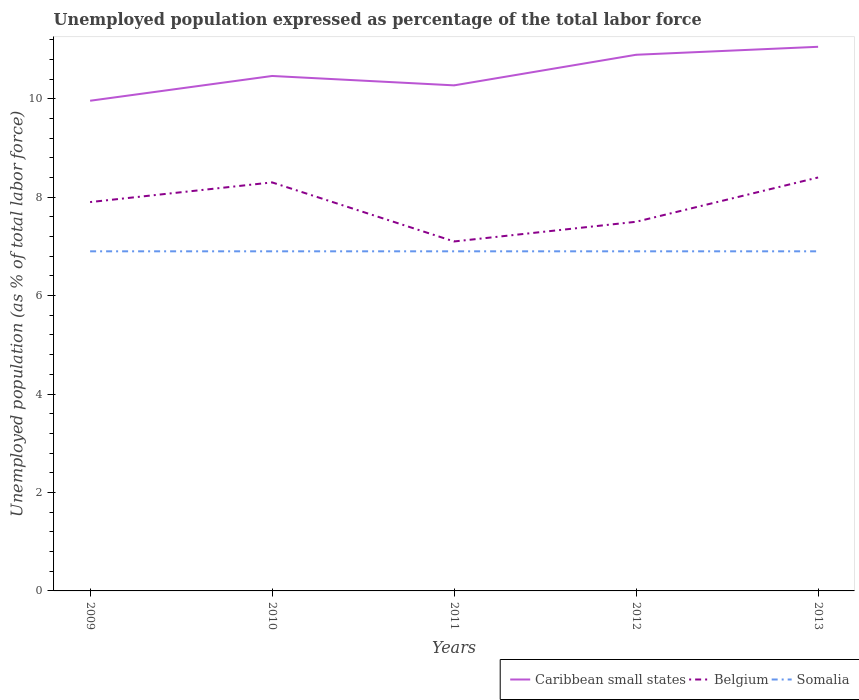Does the line corresponding to Caribbean small states intersect with the line corresponding to Somalia?
Provide a short and direct response. No. Is the number of lines equal to the number of legend labels?
Give a very brief answer. Yes. Across all years, what is the maximum unemployment in in Belgium?
Keep it short and to the point. 7.1. In which year was the unemployment in in Caribbean small states maximum?
Offer a very short reply. 2009. What is the total unemployment in in Caribbean small states in the graph?
Keep it short and to the point. -0.5. What is the difference between the highest and the second highest unemployment in in Belgium?
Offer a very short reply. 1.3. How many lines are there?
Keep it short and to the point. 3. Does the graph contain grids?
Offer a very short reply. No. Where does the legend appear in the graph?
Offer a very short reply. Bottom right. How many legend labels are there?
Offer a terse response. 3. What is the title of the graph?
Your answer should be very brief. Unemployed population expressed as percentage of the total labor force. What is the label or title of the Y-axis?
Make the answer very short. Unemployed population (as % of total labor force). What is the Unemployed population (as % of total labor force) of Caribbean small states in 2009?
Your response must be concise. 9.96. What is the Unemployed population (as % of total labor force) of Belgium in 2009?
Offer a terse response. 7.9. What is the Unemployed population (as % of total labor force) of Somalia in 2009?
Offer a very short reply. 6.9. What is the Unemployed population (as % of total labor force) of Caribbean small states in 2010?
Your response must be concise. 10.46. What is the Unemployed population (as % of total labor force) of Belgium in 2010?
Your answer should be compact. 8.3. What is the Unemployed population (as % of total labor force) of Somalia in 2010?
Give a very brief answer. 6.9. What is the Unemployed population (as % of total labor force) in Caribbean small states in 2011?
Keep it short and to the point. 10.27. What is the Unemployed population (as % of total labor force) in Belgium in 2011?
Your response must be concise. 7.1. What is the Unemployed population (as % of total labor force) of Somalia in 2011?
Provide a short and direct response. 6.9. What is the Unemployed population (as % of total labor force) in Caribbean small states in 2012?
Your answer should be very brief. 10.89. What is the Unemployed population (as % of total labor force) in Belgium in 2012?
Your answer should be compact. 7.5. What is the Unemployed population (as % of total labor force) of Somalia in 2012?
Keep it short and to the point. 6.9. What is the Unemployed population (as % of total labor force) in Caribbean small states in 2013?
Ensure brevity in your answer.  11.05. What is the Unemployed population (as % of total labor force) in Belgium in 2013?
Ensure brevity in your answer.  8.4. What is the Unemployed population (as % of total labor force) of Somalia in 2013?
Your answer should be compact. 6.9. Across all years, what is the maximum Unemployed population (as % of total labor force) of Caribbean small states?
Provide a succinct answer. 11.05. Across all years, what is the maximum Unemployed population (as % of total labor force) in Belgium?
Provide a short and direct response. 8.4. Across all years, what is the maximum Unemployed population (as % of total labor force) in Somalia?
Make the answer very short. 6.9. Across all years, what is the minimum Unemployed population (as % of total labor force) in Caribbean small states?
Offer a terse response. 9.96. Across all years, what is the minimum Unemployed population (as % of total labor force) in Belgium?
Provide a short and direct response. 7.1. Across all years, what is the minimum Unemployed population (as % of total labor force) of Somalia?
Your response must be concise. 6.9. What is the total Unemployed population (as % of total labor force) in Caribbean small states in the graph?
Provide a short and direct response. 52.64. What is the total Unemployed population (as % of total labor force) in Belgium in the graph?
Offer a very short reply. 39.2. What is the total Unemployed population (as % of total labor force) in Somalia in the graph?
Provide a succinct answer. 34.5. What is the difference between the Unemployed population (as % of total labor force) in Caribbean small states in 2009 and that in 2010?
Your answer should be compact. -0.5. What is the difference between the Unemployed population (as % of total labor force) in Somalia in 2009 and that in 2010?
Provide a short and direct response. 0. What is the difference between the Unemployed population (as % of total labor force) in Caribbean small states in 2009 and that in 2011?
Offer a very short reply. -0.31. What is the difference between the Unemployed population (as % of total labor force) of Belgium in 2009 and that in 2011?
Provide a short and direct response. 0.8. What is the difference between the Unemployed population (as % of total labor force) in Somalia in 2009 and that in 2011?
Offer a very short reply. 0. What is the difference between the Unemployed population (as % of total labor force) in Caribbean small states in 2009 and that in 2012?
Your response must be concise. -0.93. What is the difference between the Unemployed population (as % of total labor force) in Somalia in 2009 and that in 2012?
Provide a short and direct response. 0. What is the difference between the Unemployed population (as % of total labor force) of Caribbean small states in 2009 and that in 2013?
Provide a short and direct response. -1.1. What is the difference between the Unemployed population (as % of total labor force) of Somalia in 2009 and that in 2013?
Your answer should be compact. 0. What is the difference between the Unemployed population (as % of total labor force) in Caribbean small states in 2010 and that in 2011?
Your response must be concise. 0.19. What is the difference between the Unemployed population (as % of total labor force) of Belgium in 2010 and that in 2011?
Your answer should be compact. 1.2. What is the difference between the Unemployed population (as % of total labor force) in Somalia in 2010 and that in 2011?
Make the answer very short. 0. What is the difference between the Unemployed population (as % of total labor force) in Caribbean small states in 2010 and that in 2012?
Provide a short and direct response. -0.43. What is the difference between the Unemployed population (as % of total labor force) in Caribbean small states in 2010 and that in 2013?
Keep it short and to the point. -0.59. What is the difference between the Unemployed population (as % of total labor force) in Somalia in 2010 and that in 2013?
Give a very brief answer. 0. What is the difference between the Unemployed population (as % of total labor force) in Caribbean small states in 2011 and that in 2012?
Offer a terse response. -0.62. What is the difference between the Unemployed population (as % of total labor force) of Belgium in 2011 and that in 2012?
Keep it short and to the point. -0.4. What is the difference between the Unemployed population (as % of total labor force) of Caribbean small states in 2011 and that in 2013?
Keep it short and to the point. -0.78. What is the difference between the Unemployed population (as % of total labor force) in Caribbean small states in 2012 and that in 2013?
Offer a very short reply. -0.16. What is the difference between the Unemployed population (as % of total labor force) of Belgium in 2012 and that in 2013?
Your answer should be compact. -0.9. What is the difference between the Unemployed population (as % of total labor force) in Caribbean small states in 2009 and the Unemployed population (as % of total labor force) in Belgium in 2010?
Your response must be concise. 1.66. What is the difference between the Unemployed population (as % of total labor force) in Caribbean small states in 2009 and the Unemployed population (as % of total labor force) in Somalia in 2010?
Your answer should be compact. 3.06. What is the difference between the Unemployed population (as % of total labor force) of Belgium in 2009 and the Unemployed population (as % of total labor force) of Somalia in 2010?
Make the answer very short. 1. What is the difference between the Unemployed population (as % of total labor force) in Caribbean small states in 2009 and the Unemployed population (as % of total labor force) in Belgium in 2011?
Provide a succinct answer. 2.86. What is the difference between the Unemployed population (as % of total labor force) of Caribbean small states in 2009 and the Unemployed population (as % of total labor force) of Somalia in 2011?
Ensure brevity in your answer.  3.06. What is the difference between the Unemployed population (as % of total labor force) in Caribbean small states in 2009 and the Unemployed population (as % of total labor force) in Belgium in 2012?
Ensure brevity in your answer.  2.46. What is the difference between the Unemployed population (as % of total labor force) of Caribbean small states in 2009 and the Unemployed population (as % of total labor force) of Somalia in 2012?
Keep it short and to the point. 3.06. What is the difference between the Unemployed population (as % of total labor force) in Belgium in 2009 and the Unemployed population (as % of total labor force) in Somalia in 2012?
Provide a succinct answer. 1. What is the difference between the Unemployed population (as % of total labor force) in Caribbean small states in 2009 and the Unemployed population (as % of total labor force) in Belgium in 2013?
Give a very brief answer. 1.56. What is the difference between the Unemployed population (as % of total labor force) in Caribbean small states in 2009 and the Unemployed population (as % of total labor force) in Somalia in 2013?
Ensure brevity in your answer.  3.06. What is the difference between the Unemployed population (as % of total labor force) of Caribbean small states in 2010 and the Unemployed population (as % of total labor force) of Belgium in 2011?
Your answer should be compact. 3.36. What is the difference between the Unemployed population (as % of total labor force) in Caribbean small states in 2010 and the Unemployed population (as % of total labor force) in Somalia in 2011?
Provide a short and direct response. 3.56. What is the difference between the Unemployed population (as % of total labor force) in Caribbean small states in 2010 and the Unemployed population (as % of total labor force) in Belgium in 2012?
Your answer should be compact. 2.96. What is the difference between the Unemployed population (as % of total labor force) in Caribbean small states in 2010 and the Unemployed population (as % of total labor force) in Somalia in 2012?
Provide a succinct answer. 3.56. What is the difference between the Unemployed population (as % of total labor force) in Belgium in 2010 and the Unemployed population (as % of total labor force) in Somalia in 2012?
Your answer should be compact. 1.4. What is the difference between the Unemployed population (as % of total labor force) in Caribbean small states in 2010 and the Unemployed population (as % of total labor force) in Belgium in 2013?
Provide a short and direct response. 2.06. What is the difference between the Unemployed population (as % of total labor force) of Caribbean small states in 2010 and the Unemployed population (as % of total labor force) of Somalia in 2013?
Offer a very short reply. 3.56. What is the difference between the Unemployed population (as % of total labor force) of Belgium in 2010 and the Unemployed population (as % of total labor force) of Somalia in 2013?
Give a very brief answer. 1.4. What is the difference between the Unemployed population (as % of total labor force) in Caribbean small states in 2011 and the Unemployed population (as % of total labor force) in Belgium in 2012?
Keep it short and to the point. 2.77. What is the difference between the Unemployed population (as % of total labor force) of Caribbean small states in 2011 and the Unemployed population (as % of total labor force) of Somalia in 2012?
Ensure brevity in your answer.  3.37. What is the difference between the Unemployed population (as % of total labor force) of Caribbean small states in 2011 and the Unemployed population (as % of total labor force) of Belgium in 2013?
Your response must be concise. 1.87. What is the difference between the Unemployed population (as % of total labor force) in Caribbean small states in 2011 and the Unemployed population (as % of total labor force) in Somalia in 2013?
Make the answer very short. 3.37. What is the difference between the Unemployed population (as % of total labor force) of Belgium in 2011 and the Unemployed population (as % of total labor force) of Somalia in 2013?
Give a very brief answer. 0.2. What is the difference between the Unemployed population (as % of total labor force) of Caribbean small states in 2012 and the Unemployed population (as % of total labor force) of Belgium in 2013?
Provide a succinct answer. 2.49. What is the difference between the Unemployed population (as % of total labor force) of Caribbean small states in 2012 and the Unemployed population (as % of total labor force) of Somalia in 2013?
Offer a very short reply. 3.99. What is the average Unemployed population (as % of total labor force) in Caribbean small states per year?
Your answer should be compact. 10.53. What is the average Unemployed population (as % of total labor force) in Belgium per year?
Your answer should be very brief. 7.84. In the year 2009, what is the difference between the Unemployed population (as % of total labor force) in Caribbean small states and Unemployed population (as % of total labor force) in Belgium?
Your response must be concise. 2.06. In the year 2009, what is the difference between the Unemployed population (as % of total labor force) of Caribbean small states and Unemployed population (as % of total labor force) of Somalia?
Offer a very short reply. 3.06. In the year 2009, what is the difference between the Unemployed population (as % of total labor force) of Belgium and Unemployed population (as % of total labor force) of Somalia?
Ensure brevity in your answer.  1. In the year 2010, what is the difference between the Unemployed population (as % of total labor force) in Caribbean small states and Unemployed population (as % of total labor force) in Belgium?
Provide a succinct answer. 2.16. In the year 2010, what is the difference between the Unemployed population (as % of total labor force) in Caribbean small states and Unemployed population (as % of total labor force) in Somalia?
Ensure brevity in your answer.  3.56. In the year 2010, what is the difference between the Unemployed population (as % of total labor force) in Belgium and Unemployed population (as % of total labor force) in Somalia?
Offer a very short reply. 1.4. In the year 2011, what is the difference between the Unemployed population (as % of total labor force) in Caribbean small states and Unemployed population (as % of total labor force) in Belgium?
Give a very brief answer. 3.17. In the year 2011, what is the difference between the Unemployed population (as % of total labor force) of Caribbean small states and Unemployed population (as % of total labor force) of Somalia?
Your answer should be compact. 3.37. In the year 2012, what is the difference between the Unemployed population (as % of total labor force) of Caribbean small states and Unemployed population (as % of total labor force) of Belgium?
Keep it short and to the point. 3.39. In the year 2012, what is the difference between the Unemployed population (as % of total labor force) in Caribbean small states and Unemployed population (as % of total labor force) in Somalia?
Keep it short and to the point. 3.99. In the year 2013, what is the difference between the Unemployed population (as % of total labor force) in Caribbean small states and Unemployed population (as % of total labor force) in Belgium?
Give a very brief answer. 2.65. In the year 2013, what is the difference between the Unemployed population (as % of total labor force) of Caribbean small states and Unemployed population (as % of total labor force) of Somalia?
Give a very brief answer. 4.16. What is the ratio of the Unemployed population (as % of total labor force) in Caribbean small states in 2009 to that in 2010?
Provide a succinct answer. 0.95. What is the ratio of the Unemployed population (as % of total labor force) in Belgium in 2009 to that in 2010?
Make the answer very short. 0.95. What is the ratio of the Unemployed population (as % of total labor force) of Somalia in 2009 to that in 2010?
Provide a short and direct response. 1. What is the ratio of the Unemployed population (as % of total labor force) of Caribbean small states in 2009 to that in 2011?
Your answer should be very brief. 0.97. What is the ratio of the Unemployed population (as % of total labor force) in Belgium in 2009 to that in 2011?
Make the answer very short. 1.11. What is the ratio of the Unemployed population (as % of total labor force) in Somalia in 2009 to that in 2011?
Give a very brief answer. 1. What is the ratio of the Unemployed population (as % of total labor force) of Caribbean small states in 2009 to that in 2012?
Give a very brief answer. 0.91. What is the ratio of the Unemployed population (as % of total labor force) of Belgium in 2009 to that in 2012?
Give a very brief answer. 1.05. What is the ratio of the Unemployed population (as % of total labor force) of Somalia in 2009 to that in 2012?
Keep it short and to the point. 1. What is the ratio of the Unemployed population (as % of total labor force) of Caribbean small states in 2009 to that in 2013?
Offer a very short reply. 0.9. What is the ratio of the Unemployed population (as % of total labor force) in Belgium in 2009 to that in 2013?
Ensure brevity in your answer.  0.94. What is the ratio of the Unemployed population (as % of total labor force) in Somalia in 2009 to that in 2013?
Offer a very short reply. 1. What is the ratio of the Unemployed population (as % of total labor force) of Caribbean small states in 2010 to that in 2011?
Make the answer very short. 1.02. What is the ratio of the Unemployed population (as % of total labor force) in Belgium in 2010 to that in 2011?
Your response must be concise. 1.17. What is the ratio of the Unemployed population (as % of total labor force) in Somalia in 2010 to that in 2011?
Provide a succinct answer. 1. What is the ratio of the Unemployed population (as % of total labor force) in Caribbean small states in 2010 to that in 2012?
Your response must be concise. 0.96. What is the ratio of the Unemployed population (as % of total labor force) of Belgium in 2010 to that in 2012?
Your answer should be very brief. 1.11. What is the ratio of the Unemployed population (as % of total labor force) in Somalia in 2010 to that in 2012?
Offer a terse response. 1. What is the ratio of the Unemployed population (as % of total labor force) of Caribbean small states in 2010 to that in 2013?
Provide a succinct answer. 0.95. What is the ratio of the Unemployed population (as % of total labor force) of Caribbean small states in 2011 to that in 2012?
Offer a terse response. 0.94. What is the ratio of the Unemployed population (as % of total labor force) in Belgium in 2011 to that in 2012?
Your answer should be very brief. 0.95. What is the ratio of the Unemployed population (as % of total labor force) in Caribbean small states in 2011 to that in 2013?
Provide a short and direct response. 0.93. What is the ratio of the Unemployed population (as % of total labor force) of Belgium in 2011 to that in 2013?
Your answer should be compact. 0.85. What is the ratio of the Unemployed population (as % of total labor force) of Somalia in 2011 to that in 2013?
Your answer should be very brief. 1. What is the ratio of the Unemployed population (as % of total labor force) of Caribbean small states in 2012 to that in 2013?
Provide a short and direct response. 0.99. What is the ratio of the Unemployed population (as % of total labor force) in Belgium in 2012 to that in 2013?
Provide a succinct answer. 0.89. What is the ratio of the Unemployed population (as % of total labor force) in Somalia in 2012 to that in 2013?
Provide a short and direct response. 1. What is the difference between the highest and the second highest Unemployed population (as % of total labor force) in Caribbean small states?
Your answer should be very brief. 0.16. What is the difference between the highest and the second highest Unemployed population (as % of total labor force) in Belgium?
Ensure brevity in your answer.  0.1. What is the difference between the highest and the lowest Unemployed population (as % of total labor force) in Caribbean small states?
Your response must be concise. 1.1. What is the difference between the highest and the lowest Unemployed population (as % of total labor force) in Somalia?
Make the answer very short. 0. 